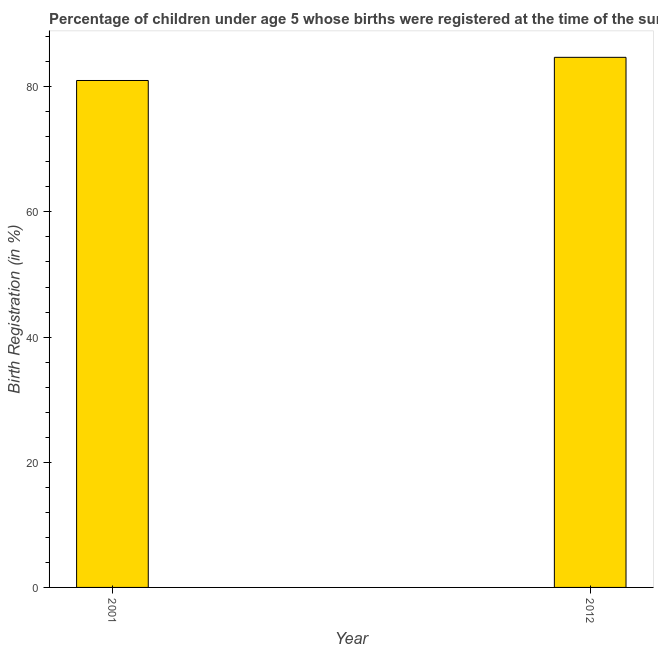Does the graph contain any zero values?
Give a very brief answer. No. What is the title of the graph?
Keep it short and to the point. Percentage of children under age 5 whose births were registered at the time of the survey in Nicaragua. What is the label or title of the X-axis?
Make the answer very short. Year. What is the label or title of the Y-axis?
Ensure brevity in your answer.  Birth Registration (in %). What is the birth registration in 2001?
Ensure brevity in your answer.  81. Across all years, what is the maximum birth registration?
Offer a very short reply. 84.7. In which year was the birth registration maximum?
Your response must be concise. 2012. In which year was the birth registration minimum?
Give a very brief answer. 2001. What is the sum of the birth registration?
Offer a very short reply. 165.7. What is the difference between the birth registration in 2001 and 2012?
Make the answer very short. -3.7. What is the average birth registration per year?
Make the answer very short. 82.85. What is the median birth registration?
Keep it short and to the point. 82.85. In how many years, is the birth registration greater than 84 %?
Provide a succinct answer. 1. What is the ratio of the birth registration in 2001 to that in 2012?
Offer a terse response. 0.96. Is the birth registration in 2001 less than that in 2012?
Provide a succinct answer. Yes. Are all the bars in the graph horizontal?
Ensure brevity in your answer.  No. How many years are there in the graph?
Offer a terse response. 2. Are the values on the major ticks of Y-axis written in scientific E-notation?
Provide a short and direct response. No. What is the Birth Registration (in %) in 2001?
Ensure brevity in your answer.  81. What is the Birth Registration (in %) in 2012?
Provide a succinct answer. 84.7. What is the ratio of the Birth Registration (in %) in 2001 to that in 2012?
Keep it short and to the point. 0.96. 